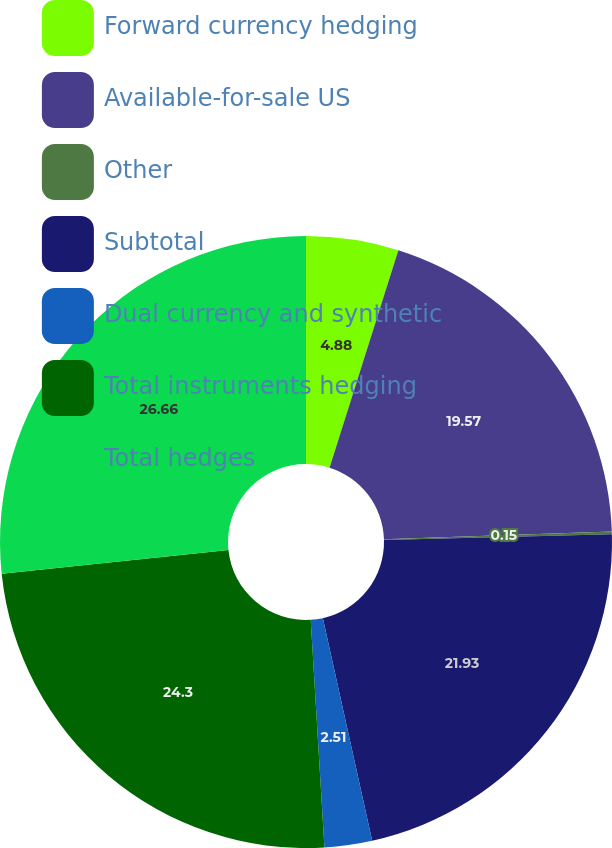<chart> <loc_0><loc_0><loc_500><loc_500><pie_chart><fcel>Forward currency hedging<fcel>Available-for-sale US<fcel>Other<fcel>Subtotal<fcel>Dual currency and synthetic<fcel>Total instruments hedging<fcel>Total hedges<nl><fcel>4.88%<fcel>19.57%<fcel>0.15%<fcel>21.93%<fcel>2.51%<fcel>24.3%<fcel>26.66%<nl></chart> 